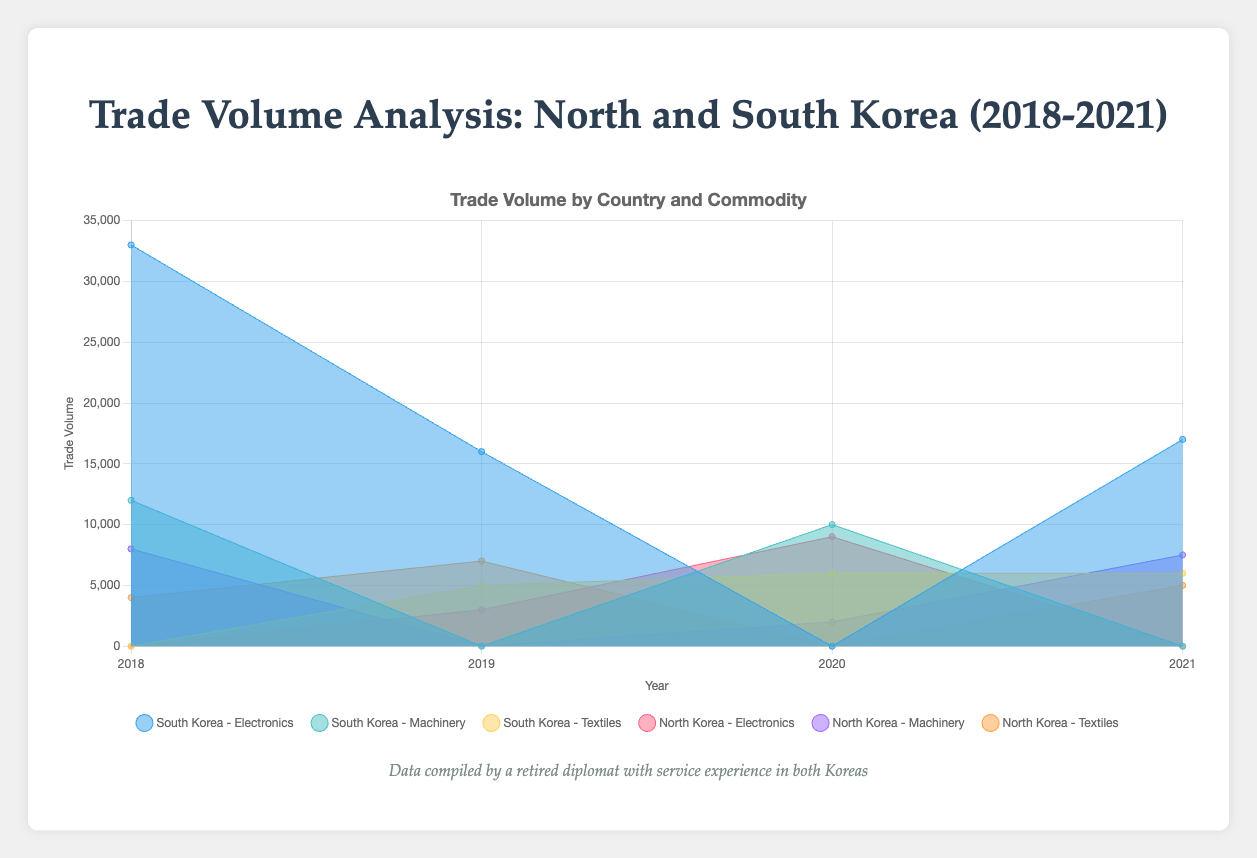Which country has the largest trade volume in electronics in 2018? To find the country with the largest trade volume in electronics in 2018, look at the area for electronics in 2018 for each country. South Korea has the highest trade volume in electronics that year.
Answer: South Korea Between 2018 and 2021, which year did South Korea trade the most in machinery? Check the trade volume in machinery for South Korea for each year. In 2018 and 2020, South Korea's machinery volumes are 12000 and 10000 respectively. So 2018 had the most.
Answer: 2018 Compare North Korea and South Korea's total trade volume in textiles in 2019. Which one is higher? Add up the trade volumes in textiles for both countries in 2019. North Korea has 7000, while South Korea has 5000. North Korea's total trade volume is higher.
Answer: North Korea What is the change in North Korea's trade volume in machinery from 2018 to 2021? Identify the trade volume for machinery in 2018 and in 2021 for North Korea. Subtract the 2018 figure (8000) from the 2021 figure (7500). The volume decreased by 500 units.
Answer: -500 Which commodity had the highest trade volume for South Korea in 2021? Compare the trade volumes for each commodity in 2021 for South Korea. Electronics have the highest trade volume at 17000 units.
Answer: Electronics What is the total trade volume between North Korea and China during the years 2018 to 2021? Sum the trade volumes between North Korea and China for each year (2018: 8000, 2019: 7000, 2020: 9000, 2021: 7500). The total is 8000 + 7000 + 9000 + 7500 = 31500 units.
Answer: 31500 How does South Korea's trade volume with China in textiles compare to North Korea's total trade volume in textiles in 2020? Look at the trade volumes in textiles for South Korea with China and North Korea's total textiles trade in 2020. South Korea's volume with China is 6000, while North Korea doesn't trade textiles with any other country than Russia, making comparison straightforward. South Korea exceeds North Korea in this comparison.
Answer: South Korea In which year did South Korea have the lowest combined trade volume across all commodities? Add up the trade volumes across all commodities for South Korea in each year, then compare to find the lowest total.
Answer: 2019 What is the average yearly trade volume in machinery between North Korea and China from 2018 to 2021? Sum the trade volumes for machinery between North Korea and China for each year (2018: 8000, 2021: 7500). Divide by the number of years traded, which is 2. Average = (8000 + 7500) / 2 = 7750.
Answer: 7750 